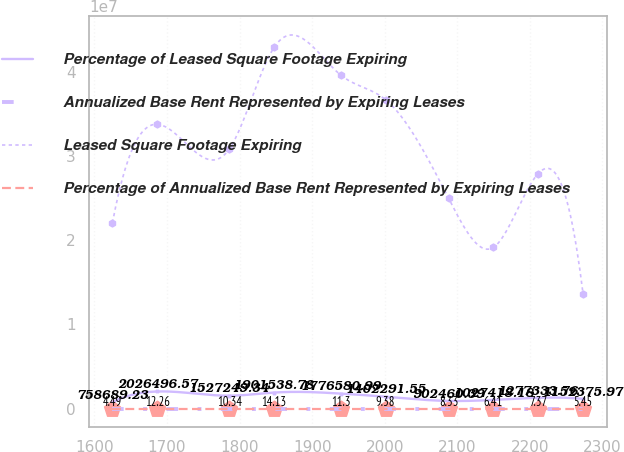Convert chart to OTSL. <chart><loc_0><loc_0><loc_500><loc_500><line_chart><ecel><fcel>Percentage of Leased Square Footage Expiring<fcel>Annualized Base Rent Represented by Expiring Leases<fcel>Leased Square Footage Expiring<fcel>Percentage of Annualized Base Rent Represented by Expiring Leases<nl><fcel>1624.75<fcel>758689<fcel>7.47<fcel>2.20942e+07<fcel>4.49<nl><fcel>1686.52<fcel>2.0265e+06<fcel>10.47<fcel>3.38103e+07<fcel>12.26<nl><fcel>1785.82<fcel>1.52725e+06<fcel>12.47<fcel>3.08813e+07<fcel>10.34<nl><fcel>1847.59<fcel>1.90154e+06<fcel>14.43<fcel>4.29655e+07<fcel>14.13<nl><fcel>1939.32<fcel>1.77658e+06<fcel>11.47<fcel>3.96684e+07<fcel>11.3<nl><fcel>2001.09<fcel>1.40229e+06<fcel>9.47<fcel>3.67393e+07<fcel>9.38<nl><fcel>2087.9<fcel>902460<fcel>8.47<fcel>2.50232e+07<fcel>8.33<nl><fcel>2149.67<fcel>1.02742e+06<fcel>4.47<fcel>1.91651e+07<fcel>6.41<nl><fcel>2211.44<fcel>1.27733e+06<fcel>5.47<fcel>2.79522e+07<fcel>7.37<nl><fcel>2273.21<fcel>1.15238e+06<fcel>6.47<fcel>1.36752e+07<fcel>5.45<nl></chart> 